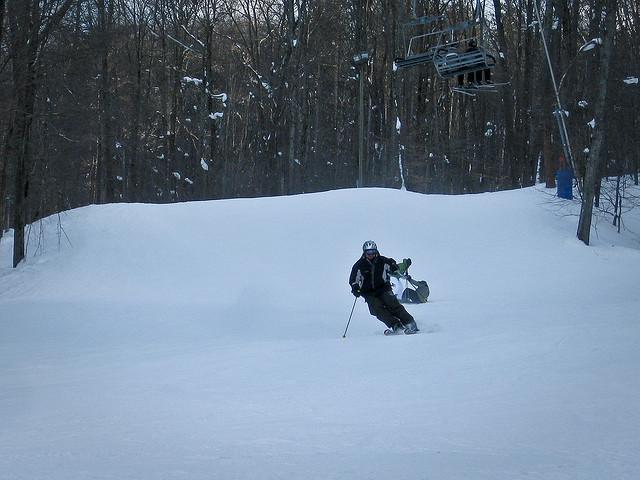How many sticks does the dog have in it's mouth?
Give a very brief answer. 0. 